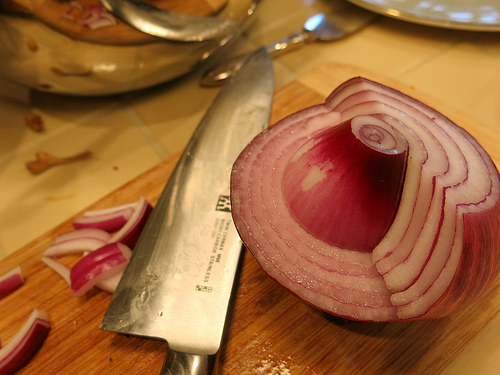<image>
Is the knife next to the onion? Yes. The knife is positioned adjacent to the onion, located nearby in the same general area. Is there a onion next to the knife? Yes. The onion is positioned adjacent to the knife, located nearby in the same general area. 